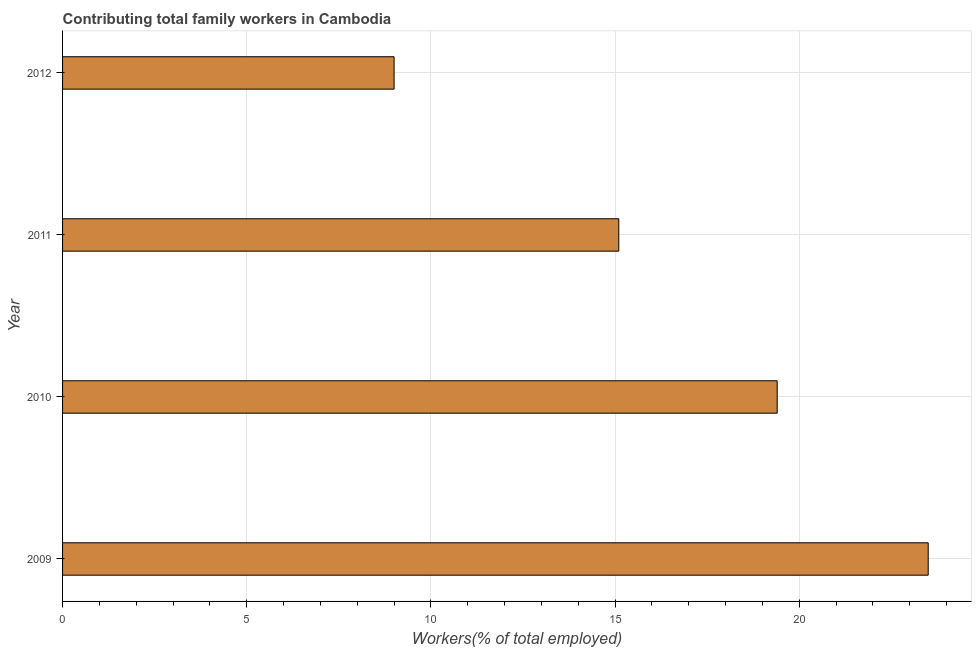Does the graph contain any zero values?
Your answer should be compact. No. Does the graph contain grids?
Provide a short and direct response. Yes. What is the title of the graph?
Keep it short and to the point. Contributing total family workers in Cambodia. What is the label or title of the X-axis?
Your response must be concise. Workers(% of total employed). What is the contributing family workers in 2010?
Provide a succinct answer. 19.4. Across all years, what is the minimum contributing family workers?
Ensure brevity in your answer.  9. In which year was the contributing family workers maximum?
Your answer should be very brief. 2009. What is the sum of the contributing family workers?
Keep it short and to the point. 67. What is the difference between the contributing family workers in 2010 and 2012?
Give a very brief answer. 10.4. What is the average contributing family workers per year?
Provide a succinct answer. 16.75. What is the median contributing family workers?
Provide a succinct answer. 17.25. Do a majority of the years between 2011 and 2012 (inclusive) have contributing family workers greater than 21 %?
Provide a succinct answer. No. What is the ratio of the contributing family workers in 2009 to that in 2011?
Your answer should be very brief. 1.56. Is the contributing family workers in 2010 less than that in 2012?
Your answer should be compact. No. Is the sum of the contributing family workers in 2010 and 2012 greater than the maximum contributing family workers across all years?
Your response must be concise. Yes. In how many years, is the contributing family workers greater than the average contributing family workers taken over all years?
Offer a terse response. 2. How many bars are there?
Your response must be concise. 4. How many years are there in the graph?
Offer a terse response. 4. What is the difference between two consecutive major ticks on the X-axis?
Offer a very short reply. 5. What is the Workers(% of total employed) in 2010?
Make the answer very short. 19.4. What is the Workers(% of total employed) of 2011?
Give a very brief answer. 15.1. What is the difference between the Workers(% of total employed) in 2009 and 2010?
Your response must be concise. 4.1. What is the difference between the Workers(% of total employed) in 2009 and 2012?
Offer a very short reply. 14.5. What is the difference between the Workers(% of total employed) in 2010 and 2011?
Your response must be concise. 4.3. What is the difference between the Workers(% of total employed) in 2010 and 2012?
Offer a terse response. 10.4. What is the ratio of the Workers(% of total employed) in 2009 to that in 2010?
Your answer should be very brief. 1.21. What is the ratio of the Workers(% of total employed) in 2009 to that in 2011?
Offer a terse response. 1.56. What is the ratio of the Workers(% of total employed) in 2009 to that in 2012?
Keep it short and to the point. 2.61. What is the ratio of the Workers(% of total employed) in 2010 to that in 2011?
Provide a short and direct response. 1.28. What is the ratio of the Workers(% of total employed) in 2010 to that in 2012?
Ensure brevity in your answer.  2.16. What is the ratio of the Workers(% of total employed) in 2011 to that in 2012?
Your answer should be very brief. 1.68. 